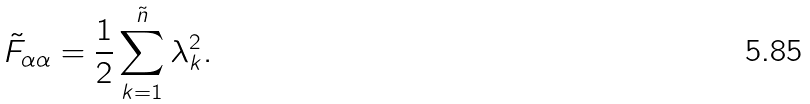Convert formula to latex. <formula><loc_0><loc_0><loc_500><loc_500>\tilde { F } _ { \alpha \alpha } = \frac { 1 } { 2 } \sum _ { k = 1 } ^ { \tilde { n } } \lambda _ { k } ^ { 2 } .</formula> 